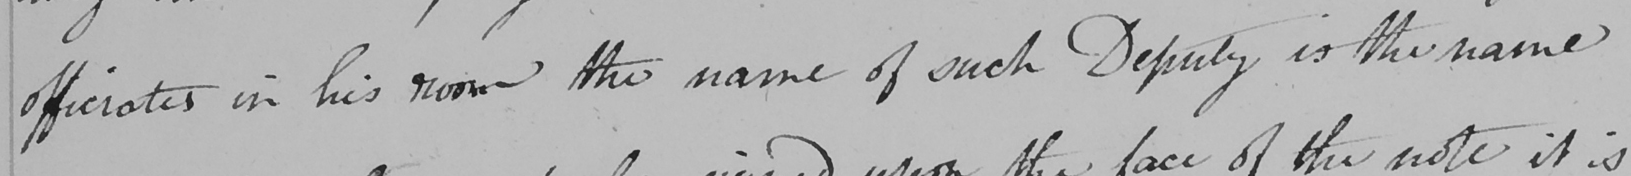Please transcribe the handwritten text in this image. officiates in his room the name of such Deputy is the name 